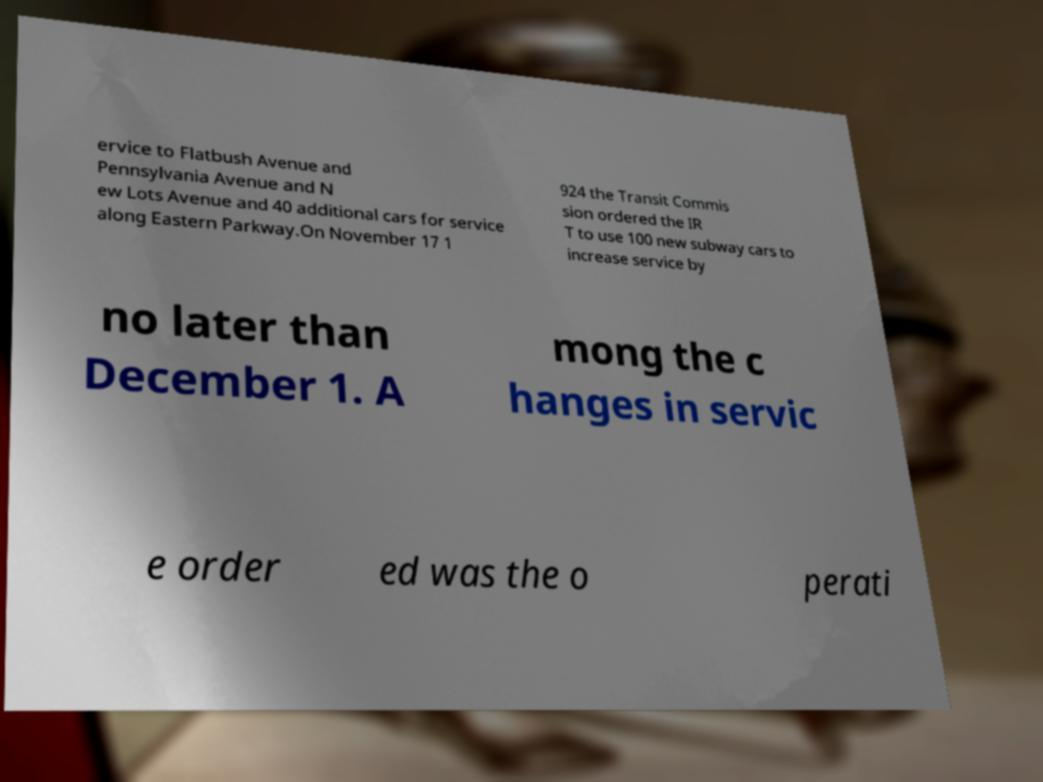Please identify and transcribe the text found in this image. ervice to Flatbush Avenue and Pennsylvania Avenue and N ew Lots Avenue and 40 additional cars for service along Eastern Parkway.On November 17 1 924 the Transit Commis sion ordered the IR T to use 100 new subway cars to increase service by no later than December 1. A mong the c hanges in servic e order ed was the o perati 